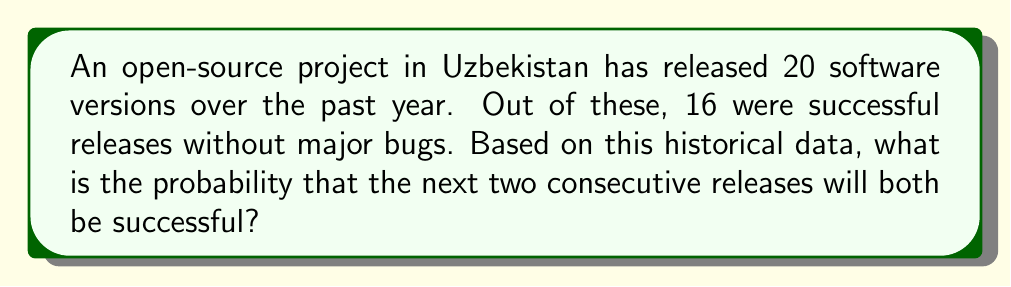Show me your answer to this math problem. Let's approach this step-by-step:

1) First, we need to calculate the probability of a single successful release:
   $$P(\text{success}) = \frac{\text{number of successful releases}}{\text{total number of releases}} = \frac{16}{20} = 0.8$$

2) Now, we need to calculate the probability of two consecutive successful releases. Since each release is independent, we can use the multiplication rule of probability:
   $$P(\text{two consecutive successes}) = P(\text{success}) \times P(\text{success})$$

3) Substituting our calculated probability:
   $$P(\text{two consecutive successes}) = 0.8 \times 0.8 = 0.64$$

4) Therefore, the probability of two consecutive successful releases is 0.64 or 64%.

This calculation assumes that past performance is indicative of future results and that each release is independent of the others.
Answer: 0.64 